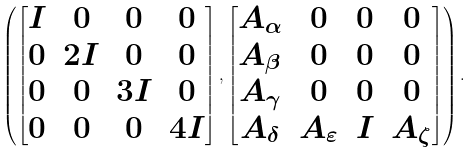Convert formula to latex. <formula><loc_0><loc_0><loc_500><loc_500>\left ( \begin{bmatrix} I & 0 & 0 & 0 \\ 0 & 2 I & 0 & 0 \\ 0 & 0 & 3 I & 0 \\ 0 & 0 & 0 & 4 I \end{bmatrix} , \begin{bmatrix} A _ { \alpha } & 0 & 0 & 0 \\ A _ { \beta } & 0 & 0 & 0 \\ A _ { \gamma } & 0 & 0 & 0 \\ A _ { \delta } & A _ { \varepsilon } & I & A _ { \zeta } \end{bmatrix} \right ) .</formula> 